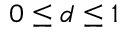Convert formula to latex. <formula><loc_0><loc_0><loc_500><loc_500>0 \leq d \leq 1</formula> 